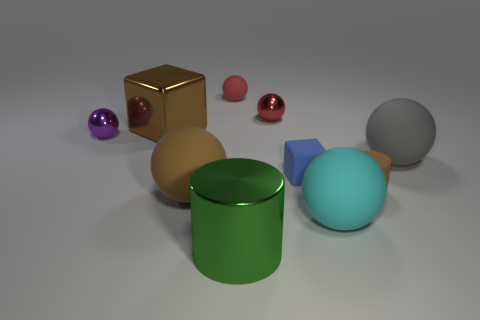Subtract all gray spheres. How many spheres are left? 5 Subtract all green cylinders. How many cylinders are left? 1 Subtract all cylinders. How many objects are left? 8 Subtract 2 blocks. How many blocks are left? 0 Add 4 metal objects. How many metal objects are left? 8 Add 4 tiny shiny objects. How many tiny shiny objects exist? 6 Subtract 0 gray cubes. How many objects are left? 10 Subtract all gray cylinders. Subtract all yellow blocks. How many cylinders are left? 2 Subtract all yellow balls. How many brown cylinders are left? 1 Subtract all big gray rubber blocks. Subtract all brown metallic things. How many objects are left? 9 